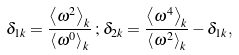Convert formula to latex. <formula><loc_0><loc_0><loc_500><loc_500>\delta _ { 1 { k } } = \frac { \left \langle \omega ^ { 2 } \right \rangle _ { k } } { \left \langle \omega ^ { 0 } \right \rangle _ { k } } \, ; \, \delta _ { 2 { k } } = \frac { \left \langle \omega ^ { 4 } \right \rangle _ { k } } { \left \langle \omega ^ { 2 } \right \rangle _ { k } } - \delta _ { 1 { k } } ,</formula> 